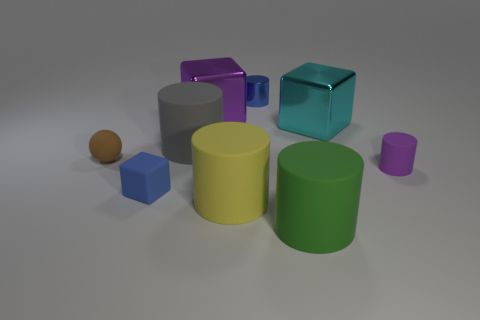Can you describe the arrangement of shapes in terms of their colors and sizes? Certainly! In the image, we have an array of geometric shapes with varying colors and sizes. Starting from the largest, there's a purple cylindrical block and a yellow cylindrical block, both large but the purple one is slightly taller. A medium-sized teal cube sits between the cylinders. To its right, there's a small purple cylinder, and to the left, a medium-sized grey cube. Additionally, we observe two small shapes: a blue cube and a brown sphere. 